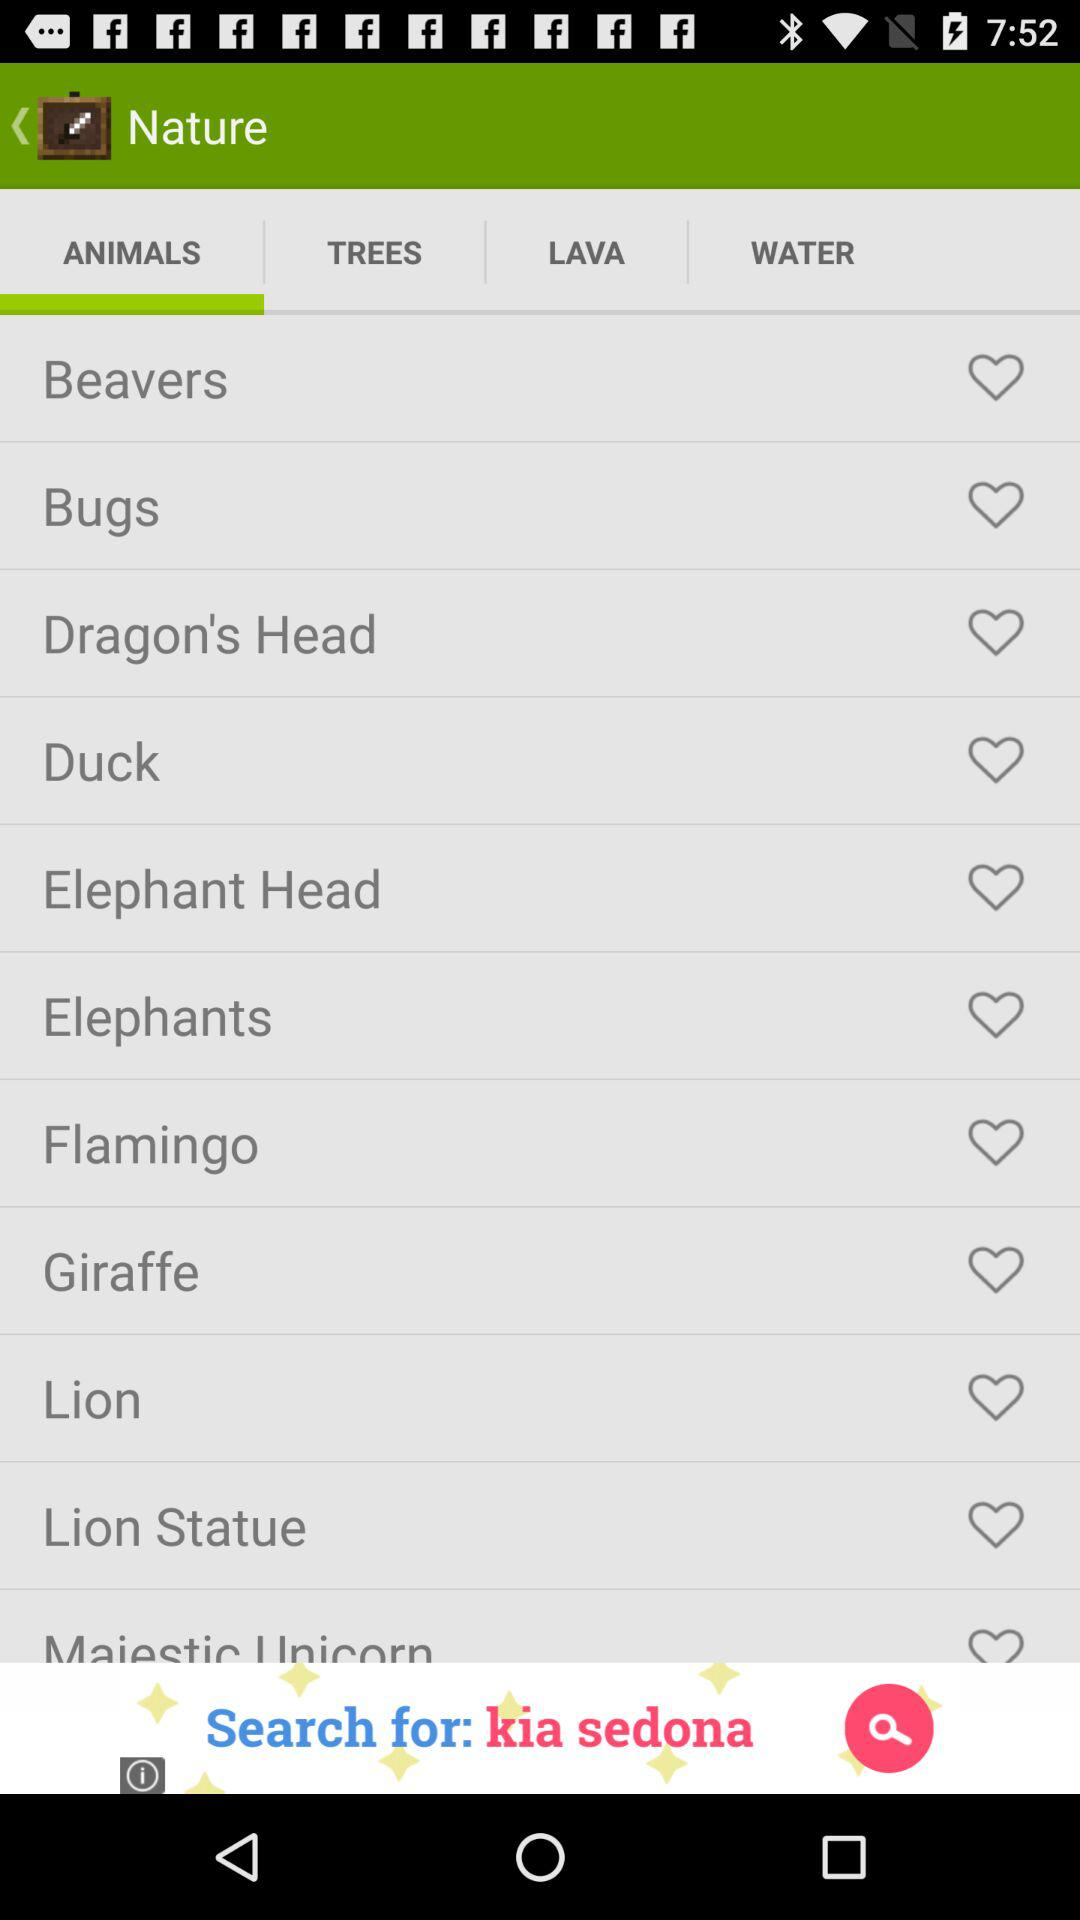Which tab is selected? The selected tab is "ANIMALS". 